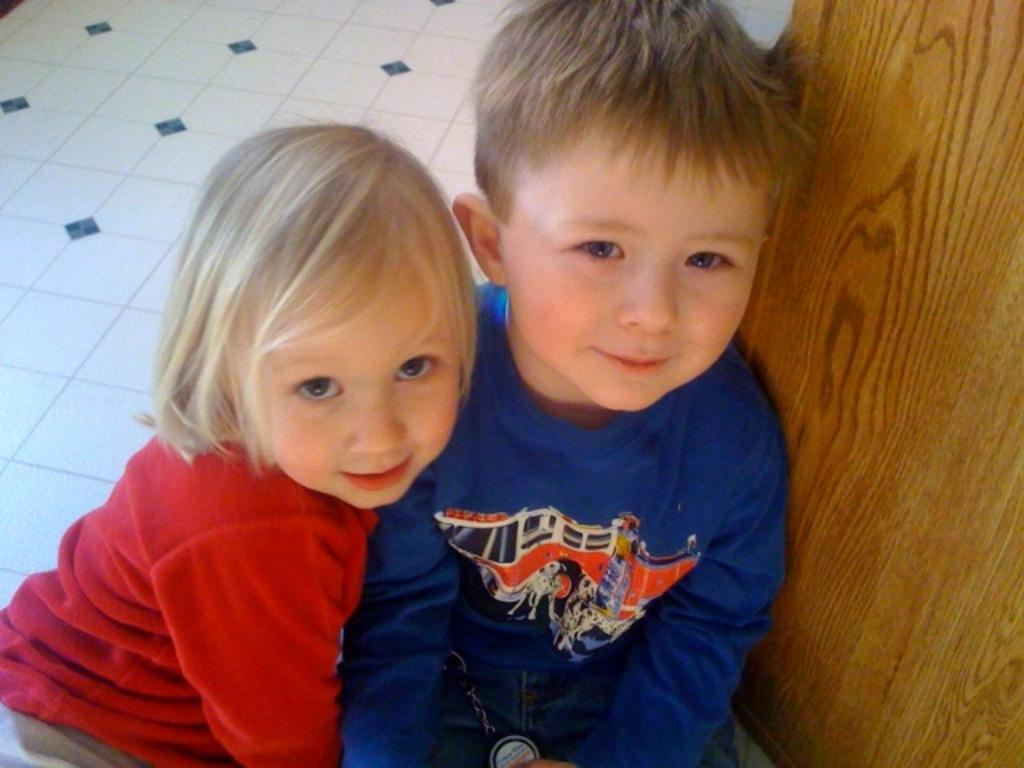How many people are in the image? There are two persons sitting on the floor in the image. What are the people doing in the image? The question does not specify any actions, so we cannot determine what the people are doing. What type of object can be seen at the side in the image? There is a wooden object at the side in the image. What type of quill is being used by the person in the image? There is no quill present in the image. How does the spark from the wooden object affect the people in the image? There is no spark present in the image, so it cannot affect the people. 